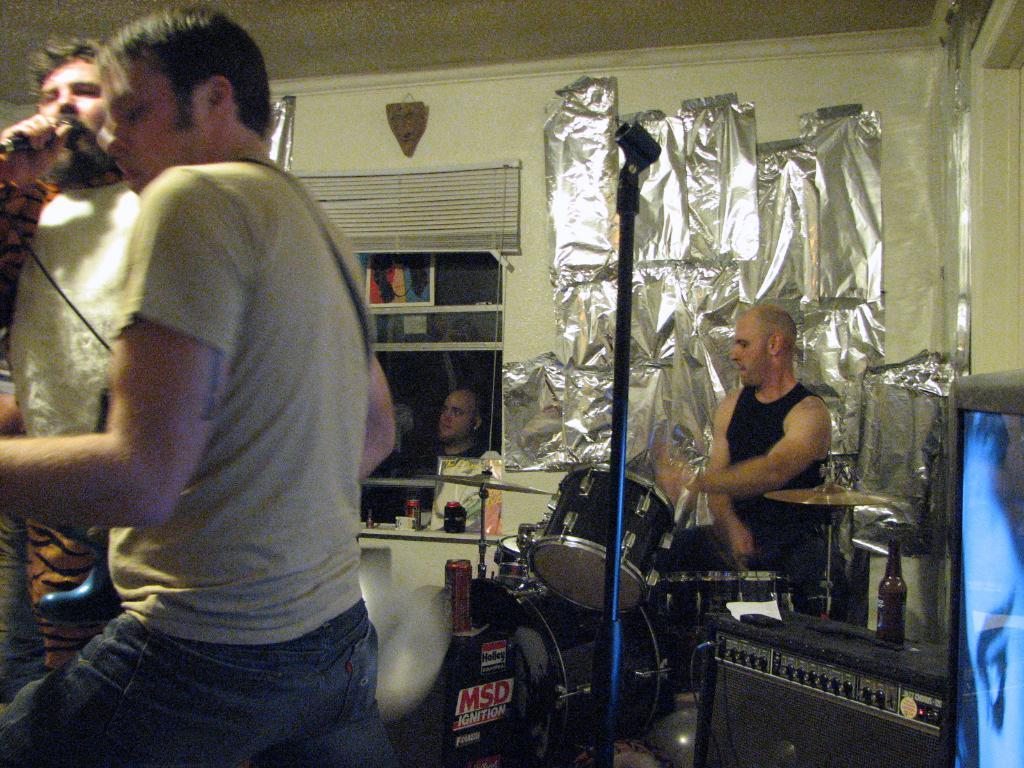Could you give a brief overview of what you see in this image? This picture shows a man seated and playing drums and we see a man Standing and holding a guitar in his hand and we see other man holding a microphone and singing and we see other man watching it from the window and we see blinds to the window and we see a silver paper on the wall 